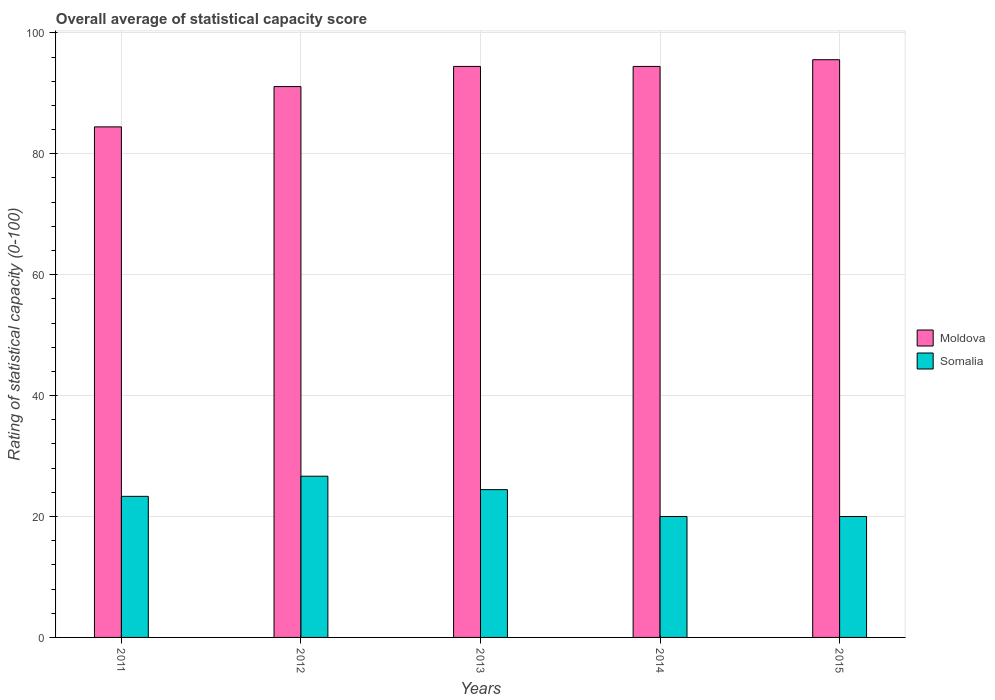How many different coloured bars are there?
Ensure brevity in your answer.  2. Are the number of bars per tick equal to the number of legend labels?
Offer a terse response. Yes. How many bars are there on the 2nd tick from the left?
Offer a very short reply. 2. How many bars are there on the 3rd tick from the right?
Provide a short and direct response. 2. In how many cases, is the number of bars for a given year not equal to the number of legend labels?
Keep it short and to the point. 0. What is the rating of statistical capacity in Moldova in 2014?
Your answer should be compact. 94.44. Across all years, what is the maximum rating of statistical capacity in Moldova?
Offer a terse response. 95.56. Across all years, what is the minimum rating of statistical capacity in Somalia?
Make the answer very short. 20. In which year was the rating of statistical capacity in Moldova maximum?
Provide a succinct answer. 2015. What is the total rating of statistical capacity in Moldova in the graph?
Keep it short and to the point. 460. What is the difference between the rating of statistical capacity in Moldova in 2014 and that in 2015?
Provide a succinct answer. -1.11. What is the difference between the rating of statistical capacity in Moldova in 2011 and the rating of statistical capacity in Somalia in 2013?
Offer a terse response. 60. What is the average rating of statistical capacity in Moldova per year?
Offer a terse response. 92. In the year 2011, what is the difference between the rating of statistical capacity in Somalia and rating of statistical capacity in Moldova?
Give a very brief answer. -61.11. In how many years, is the rating of statistical capacity in Somalia greater than 24?
Offer a very short reply. 2. What is the ratio of the rating of statistical capacity in Moldova in 2012 to that in 2014?
Your response must be concise. 0.96. Is the rating of statistical capacity in Somalia in 2011 less than that in 2012?
Give a very brief answer. Yes. What is the difference between the highest and the second highest rating of statistical capacity in Moldova?
Your answer should be compact. 1.11. What is the difference between the highest and the lowest rating of statistical capacity in Moldova?
Provide a succinct answer. 11.11. Is the sum of the rating of statistical capacity in Moldova in 2013 and 2015 greater than the maximum rating of statistical capacity in Somalia across all years?
Provide a succinct answer. Yes. What does the 2nd bar from the left in 2012 represents?
Offer a very short reply. Somalia. What does the 2nd bar from the right in 2013 represents?
Your answer should be compact. Moldova. How many bars are there?
Offer a terse response. 10. Are all the bars in the graph horizontal?
Your answer should be very brief. No. How many years are there in the graph?
Your answer should be compact. 5. Does the graph contain any zero values?
Offer a terse response. No. Does the graph contain grids?
Your answer should be compact. Yes. Where does the legend appear in the graph?
Make the answer very short. Center right. How many legend labels are there?
Your response must be concise. 2. What is the title of the graph?
Offer a terse response. Overall average of statistical capacity score. Does "Hong Kong" appear as one of the legend labels in the graph?
Provide a short and direct response. No. What is the label or title of the X-axis?
Make the answer very short. Years. What is the label or title of the Y-axis?
Offer a terse response. Rating of statistical capacity (0-100). What is the Rating of statistical capacity (0-100) in Moldova in 2011?
Your answer should be compact. 84.44. What is the Rating of statistical capacity (0-100) in Somalia in 2011?
Offer a very short reply. 23.33. What is the Rating of statistical capacity (0-100) in Moldova in 2012?
Your answer should be compact. 91.11. What is the Rating of statistical capacity (0-100) in Somalia in 2012?
Offer a very short reply. 26.67. What is the Rating of statistical capacity (0-100) of Moldova in 2013?
Provide a succinct answer. 94.44. What is the Rating of statistical capacity (0-100) in Somalia in 2013?
Provide a short and direct response. 24.44. What is the Rating of statistical capacity (0-100) in Moldova in 2014?
Make the answer very short. 94.44. What is the Rating of statistical capacity (0-100) of Moldova in 2015?
Keep it short and to the point. 95.56. What is the Rating of statistical capacity (0-100) of Somalia in 2015?
Offer a very short reply. 20. Across all years, what is the maximum Rating of statistical capacity (0-100) in Moldova?
Your response must be concise. 95.56. Across all years, what is the maximum Rating of statistical capacity (0-100) of Somalia?
Offer a terse response. 26.67. Across all years, what is the minimum Rating of statistical capacity (0-100) in Moldova?
Make the answer very short. 84.44. Across all years, what is the minimum Rating of statistical capacity (0-100) of Somalia?
Keep it short and to the point. 20. What is the total Rating of statistical capacity (0-100) of Moldova in the graph?
Give a very brief answer. 460. What is the total Rating of statistical capacity (0-100) in Somalia in the graph?
Make the answer very short. 114.44. What is the difference between the Rating of statistical capacity (0-100) of Moldova in 2011 and that in 2012?
Offer a terse response. -6.67. What is the difference between the Rating of statistical capacity (0-100) of Somalia in 2011 and that in 2012?
Give a very brief answer. -3.33. What is the difference between the Rating of statistical capacity (0-100) of Moldova in 2011 and that in 2013?
Provide a short and direct response. -10. What is the difference between the Rating of statistical capacity (0-100) of Somalia in 2011 and that in 2013?
Keep it short and to the point. -1.11. What is the difference between the Rating of statistical capacity (0-100) of Moldova in 2011 and that in 2015?
Offer a terse response. -11.11. What is the difference between the Rating of statistical capacity (0-100) in Somalia in 2011 and that in 2015?
Your answer should be very brief. 3.33. What is the difference between the Rating of statistical capacity (0-100) in Somalia in 2012 and that in 2013?
Your response must be concise. 2.22. What is the difference between the Rating of statistical capacity (0-100) in Moldova in 2012 and that in 2015?
Offer a terse response. -4.44. What is the difference between the Rating of statistical capacity (0-100) of Moldova in 2013 and that in 2014?
Provide a short and direct response. 0. What is the difference between the Rating of statistical capacity (0-100) of Somalia in 2013 and that in 2014?
Your answer should be compact. 4.44. What is the difference between the Rating of statistical capacity (0-100) of Moldova in 2013 and that in 2015?
Provide a short and direct response. -1.11. What is the difference between the Rating of statistical capacity (0-100) in Somalia in 2013 and that in 2015?
Make the answer very short. 4.44. What is the difference between the Rating of statistical capacity (0-100) of Moldova in 2014 and that in 2015?
Give a very brief answer. -1.11. What is the difference between the Rating of statistical capacity (0-100) in Moldova in 2011 and the Rating of statistical capacity (0-100) in Somalia in 2012?
Make the answer very short. 57.78. What is the difference between the Rating of statistical capacity (0-100) in Moldova in 2011 and the Rating of statistical capacity (0-100) in Somalia in 2014?
Offer a very short reply. 64.44. What is the difference between the Rating of statistical capacity (0-100) of Moldova in 2011 and the Rating of statistical capacity (0-100) of Somalia in 2015?
Provide a succinct answer. 64.44. What is the difference between the Rating of statistical capacity (0-100) of Moldova in 2012 and the Rating of statistical capacity (0-100) of Somalia in 2013?
Your answer should be compact. 66.67. What is the difference between the Rating of statistical capacity (0-100) in Moldova in 2012 and the Rating of statistical capacity (0-100) in Somalia in 2014?
Your answer should be very brief. 71.11. What is the difference between the Rating of statistical capacity (0-100) of Moldova in 2012 and the Rating of statistical capacity (0-100) of Somalia in 2015?
Provide a succinct answer. 71.11. What is the difference between the Rating of statistical capacity (0-100) of Moldova in 2013 and the Rating of statistical capacity (0-100) of Somalia in 2014?
Make the answer very short. 74.44. What is the difference between the Rating of statistical capacity (0-100) in Moldova in 2013 and the Rating of statistical capacity (0-100) in Somalia in 2015?
Your answer should be compact. 74.44. What is the difference between the Rating of statistical capacity (0-100) of Moldova in 2014 and the Rating of statistical capacity (0-100) of Somalia in 2015?
Provide a succinct answer. 74.44. What is the average Rating of statistical capacity (0-100) of Moldova per year?
Your answer should be compact. 92. What is the average Rating of statistical capacity (0-100) in Somalia per year?
Make the answer very short. 22.89. In the year 2011, what is the difference between the Rating of statistical capacity (0-100) in Moldova and Rating of statistical capacity (0-100) in Somalia?
Offer a terse response. 61.11. In the year 2012, what is the difference between the Rating of statistical capacity (0-100) of Moldova and Rating of statistical capacity (0-100) of Somalia?
Provide a short and direct response. 64.44. In the year 2014, what is the difference between the Rating of statistical capacity (0-100) in Moldova and Rating of statistical capacity (0-100) in Somalia?
Your response must be concise. 74.44. In the year 2015, what is the difference between the Rating of statistical capacity (0-100) of Moldova and Rating of statistical capacity (0-100) of Somalia?
Make the answer very short. 75.56. What is the ratio of the Rating of statistical capacity (0-100) of Moldova in 2011 to that in 2012?
Your response must be concise. 0.93. What is the ratio of the Rating of statistical capacity (0-100) of Moldova in 2011 to that in 2013?
Keep it short and to the point. 0.89. What is the ratio of the Rating of statistical capacity (0-100) in Somalia in 2011 to that in 2013?
Give a very brief answer. 0.95. What is the ratio of the Rating of statistical capacity (0-100) of Moldova in 2011 to that in 2014?
Provide a short and direct response. 0.89. What is the ratio of the Rating of statistical capacity (0-100) in Moldova in 2011 to that in 2015?
Offer a very short reply. 0.88. What is the ratio of the Rating of statistical capacity (0-100) of Somalia in 2011 to that in 2015?
Your answer should be compact. 1.17. What is the ratio of the Rating of statistical capacity (0-100) in Moldova in 2012 to that in 2013?
Keep it short and to the point. 0.96. What is the ratio of the Rating of statistical capacity (0-100) of Moldova in 2012 to that in 2014?
Provide a short and direct response. 0.96. What is the ratio of the Rating of statistical capacity (0-100) of Somalia in 2012 to that in 2014?
Your answer should be compact. 1.33. What is the ratio of the Rating of statistical capacity (0-100) in Moldova in 2012 to that in 2015?
Offer a very short reply. 0.95. What is the ratio of the Rating of statistical capacity (0-100) in Somalia in 2013 to that in 2014?
Keep it short and to the point. 1.22. What is the ratio of the Rating of statistical capacity (0-100) in Moldova in 2013 to that in 2015?
Provide a succinct answer. 0.99. What is the ratio of the Rating of statistical capacity (0-100) in Somalia in 2013 to that in 2015?
Provide a short and direct response. 1.22. What is the ratio of the Rating of statistical capacity (0-100) in Moldova in 2014 to that in 2015?
Give a very brief answer. 0.99. What is the ratio of the Rating of statistical capacity (0-100) of Somalia in 2014 to that in 2015?
Your response must be concise. 1. What is the difference between the highest and the second highest Rating of statistical capacity (0-100) in Somalia?
Ensure brevity in your answer.  2.22. What is the difference between the highest and the lowest Rating of statistical capacity (0-100) of Moldova?
Provide a short and direct response. 11.11. 